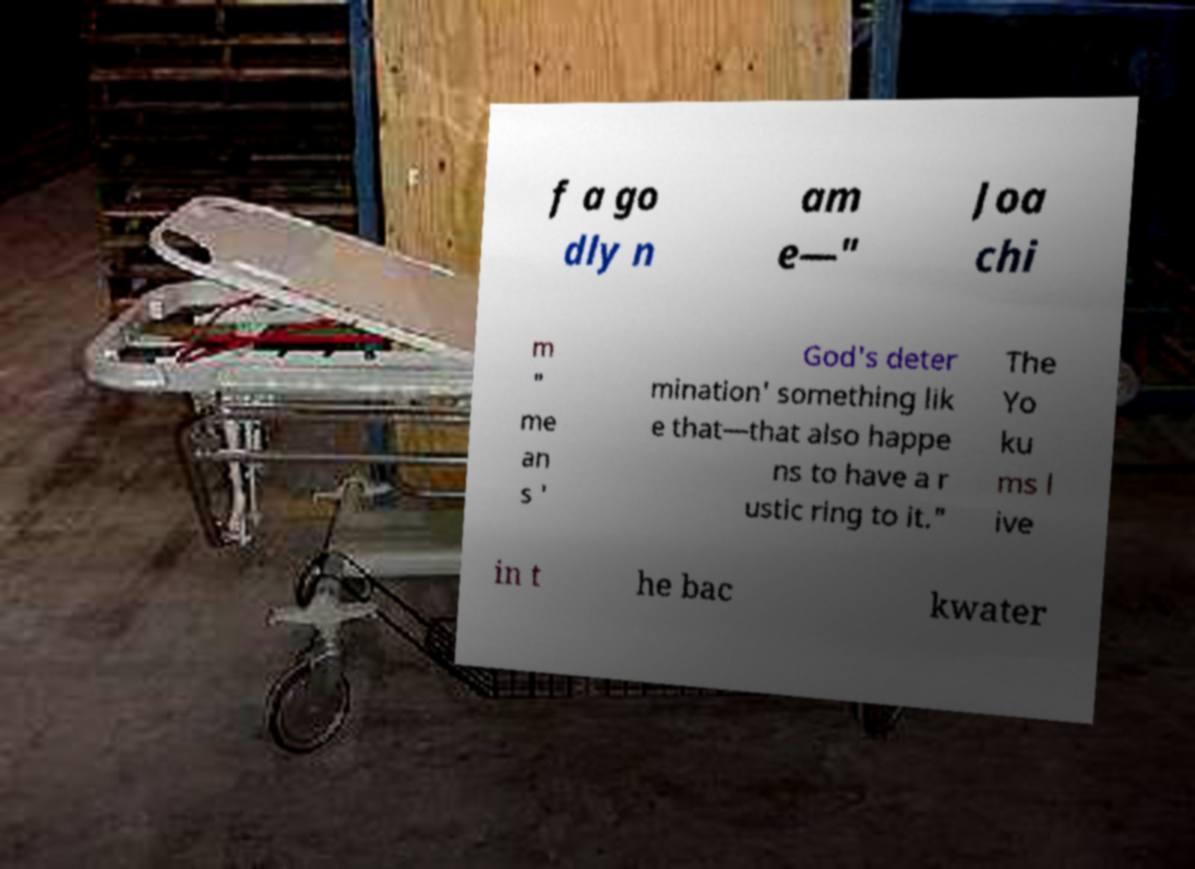Please read and relay the text visible in this image. What does it say? f a go dly n am e—" Joa chi m " me an s ' God's deter mination' something lik e that—that also happe ns to have a r ustic ring to it." The Yo ku ms l ive in t he bac kwater 